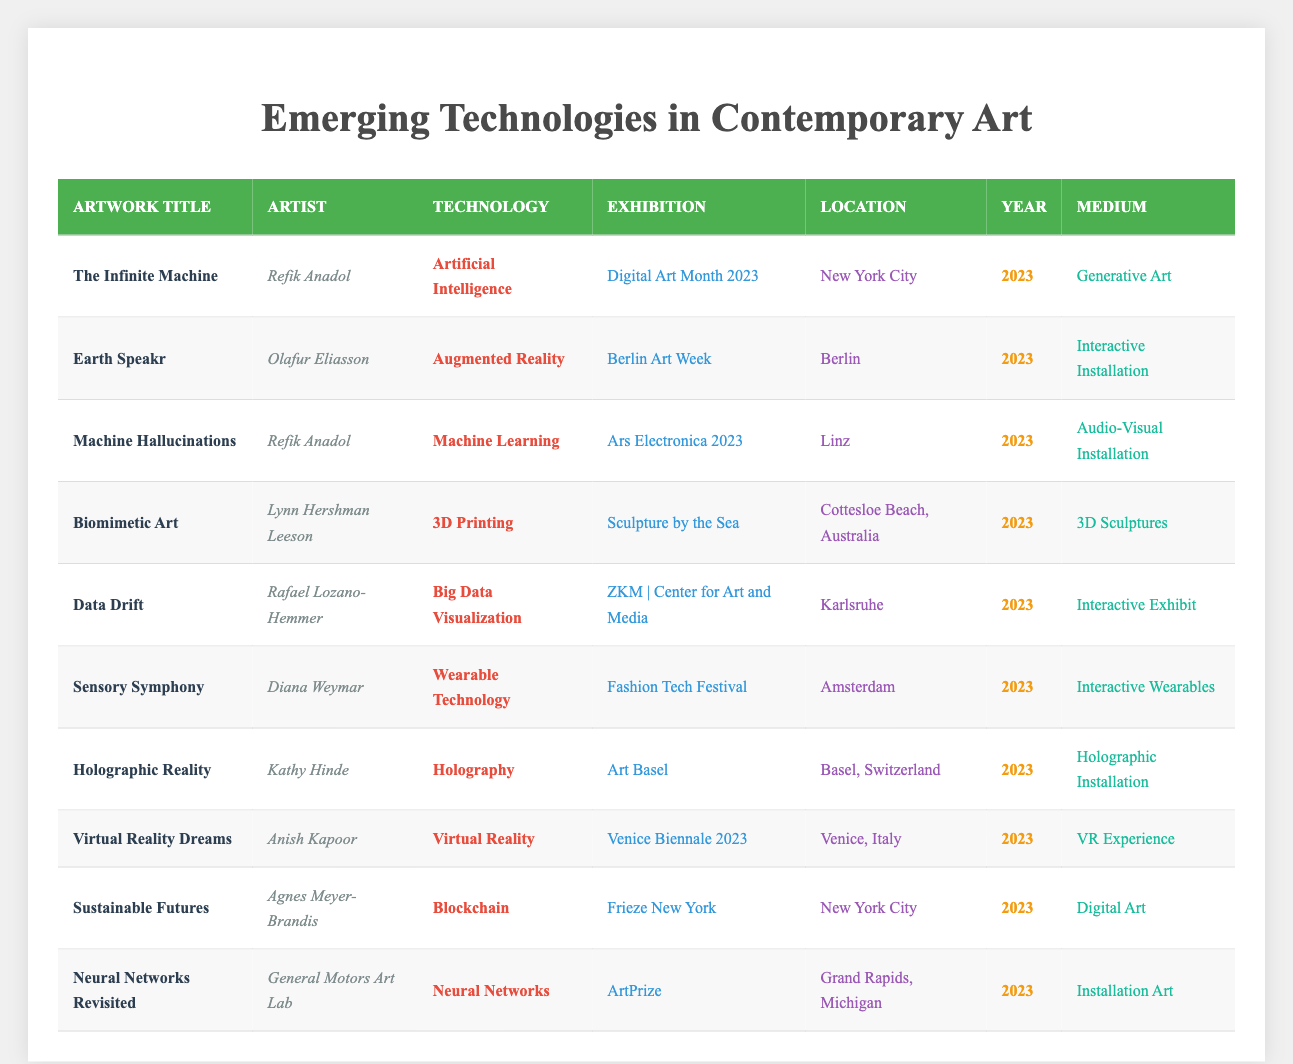What is the technology used in "The Infinite Machine"? The artwork "The Infinite Machine" utilizes Artificial Intelligence as its technology. This is directly stated in the table under the technology column for this artwork.
Answer: Artificial Intelligence How many artworks featured Machine Learning? By scanning the table for the technology column, I can see that there is one artwork listed that uses Machine Learning, which is "Machine Hallucinations" by Refik Anadol.
Answer: 1 Which medium is used for the artwork titled "Sustainable Futures"? The table shows that the medium for "Sustainable Futures" is Digital Art. This information is directly present in the corresponding row of the table.
Answer: Digital Art What is the total number of artworks listed in the table? There are 10 artworks presented in the table. To find this, I can count the number of rows under the artwork title entries.
Answer: 10 How many different technologies are featured in the showcased artworks? The technology column of the table lists 8 unique technologies: Artificial Intelligence, Augmented Reality, Machine Learning, 3D Printing, Big Data Visualization, Wearable Technology, Holography, and Virtual Reality. This requires some scanning of the technology column to identify each unique entry.
Answer: 8 Which artist has the most artworks featured in this table? Refik Anadol is the artist with the most artworks featured, showcasing two pieces: "The Infinite Machine" and "Machine Hallucinations." I determined this by checking the artist column and counting the mentions.
Answer: Refik Anadol Are there any artworks using Blockchain technology? Yes, "Sustainable Futures" by Agnes Meyer-Brandis utilizes Blockchain technology as mentioned in the technology column of the artwork entry.
Answer: Yes How many artworks are located in New York City, and what are their titles? There are two artworks located in New York City: "The Infinite Machine" and "Sustainable Futures." To find this, I checked the location column for New York City and noted the corresponding artwork titles.
Answer: 2, "The Infinite Machine" and "Sustainable Futures" 